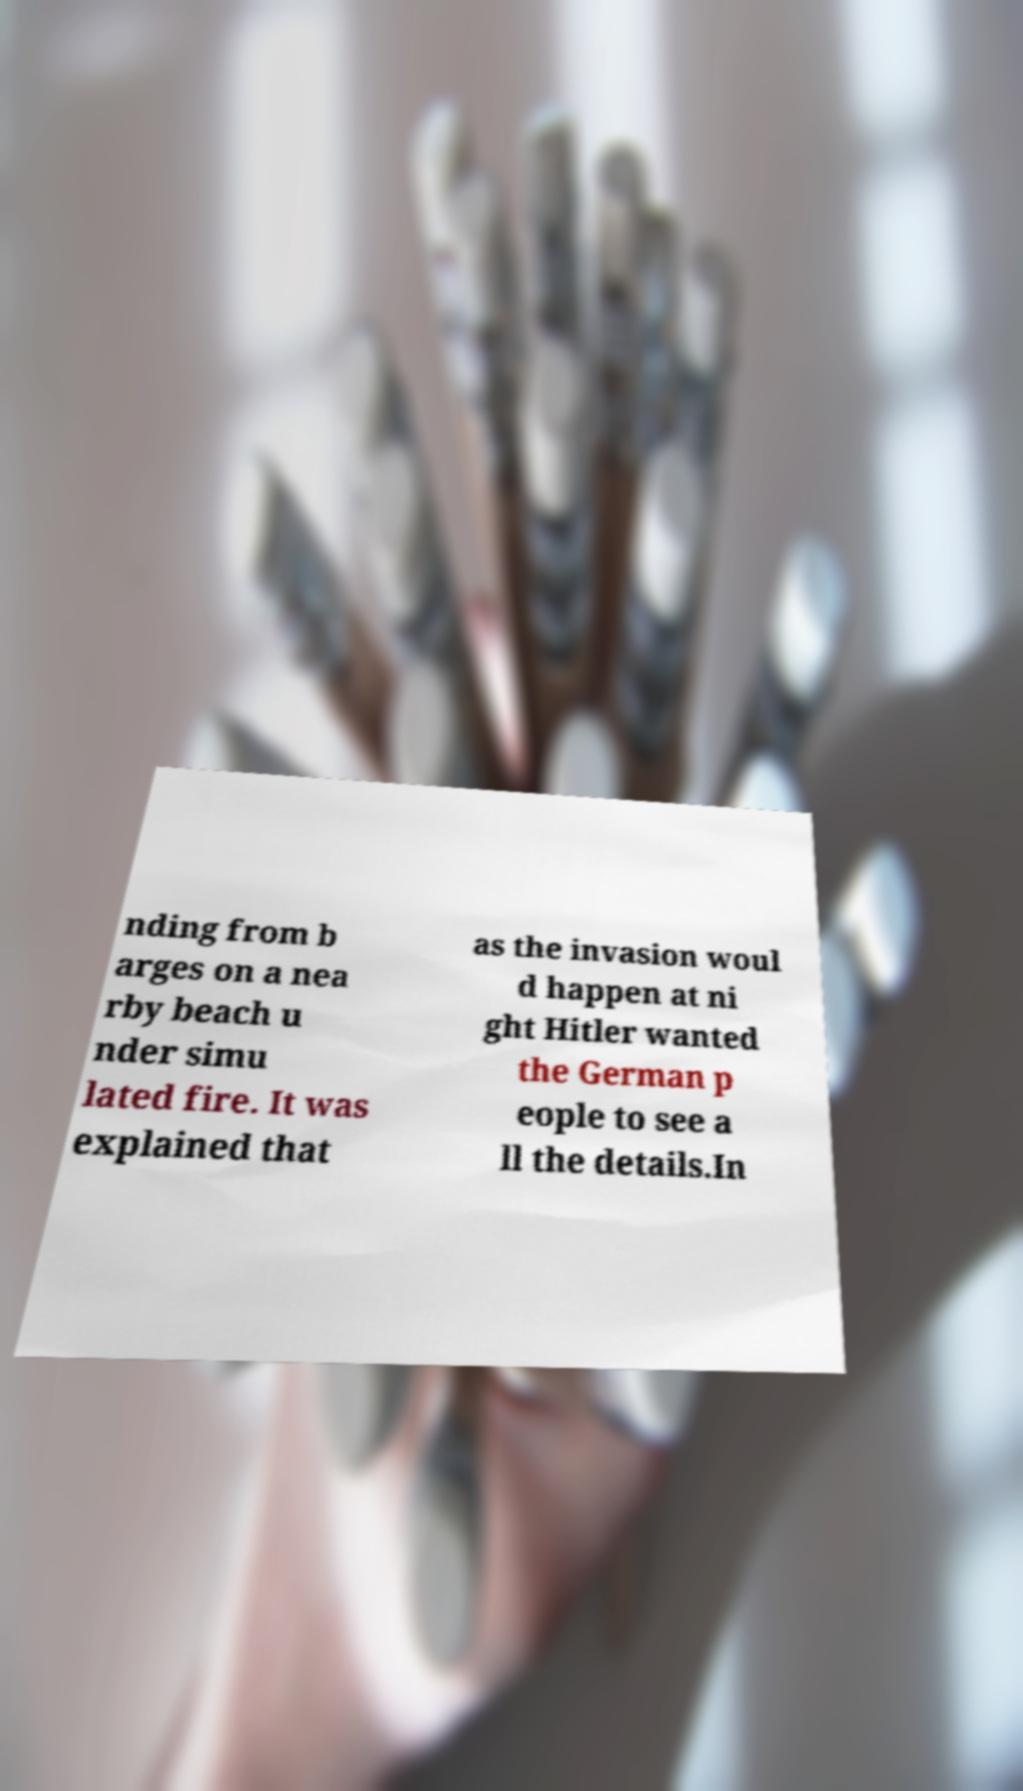Could you extract and type out the text from this image? nding from b arges on a nea rby beach u nder simu lated fire. It was explained that as the invasion woul d happen at ni ght Hitler wanted the German p eople to see a ll the details.In 